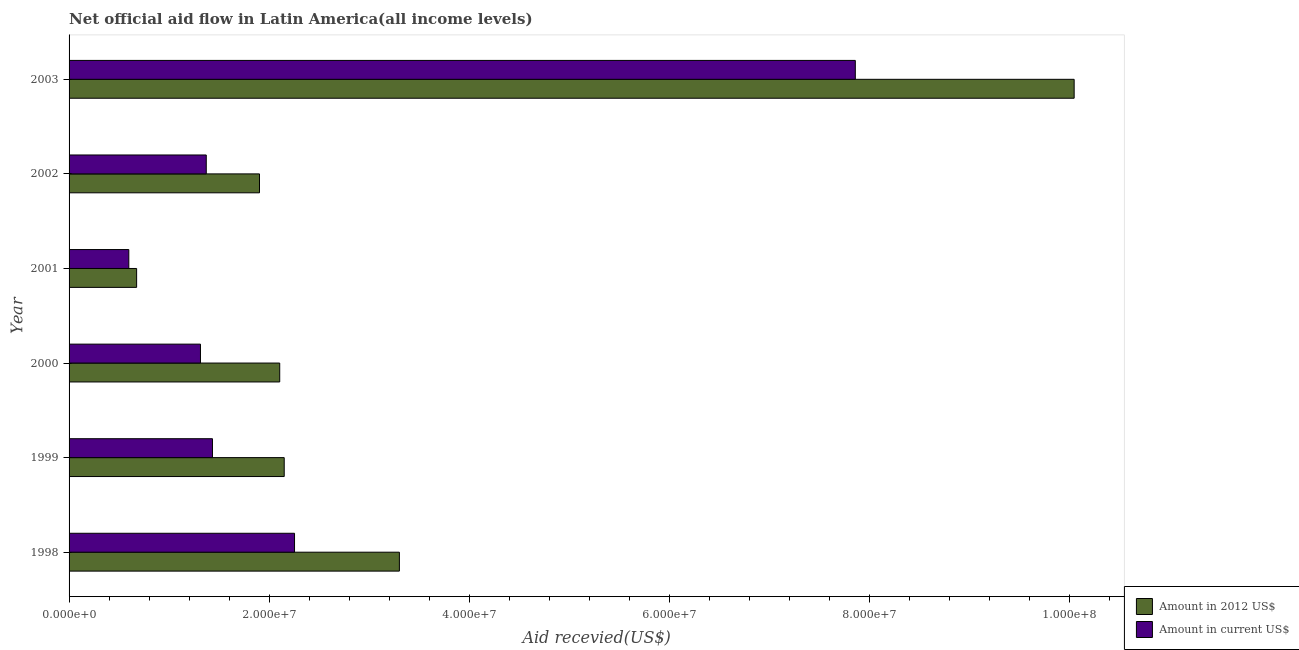How many bars are there on the 4th tick from the bottom?
Provide a short and direct response. 2. What is the amount of aid received(expressed in 2012 us$) in 1999?
Provide a short and direct response. 2.15e+07. Across all years, what is the maximum amount of aid received(expressed in 2012 us$)?
Provide a short and direct response. 1.00e+08. Across all years, what is the minimum amount of aid received(expressed in us$)?
Give a very brief answer. 5.97e+06. In which year was the amount of aid received(expressed in us$) maximum?
Your response must be concise. 2003. In which year was the amount of aid received(expressed in 2012 us$) minimum?
Keep it short and to the point. 2001. What is the total amount of aid received(expressed in 2012 us$) in the graph?
Provide a short and direct response. 2.02e+08. What is the difference between the amount of aid received(expressed in 2012 us$) in 1999 and that in 2002?
Provide a succinct answer. 2.47e+06. What is the difference between the amount of aid received(expressed in 2012 us$) in 1998 and the amount of aid received(expressed in us$) in 2000?
Your answer should be compact. 1.99e+07. What is the average amount of aid received(expressed in us$) per year?
Provide a short and direct response. 2.47e+07. In the year 2000, what is the difference between the amount of aid received(expressed in us$) and amount of aid received(expressed in 2012 us$)?
Ensure brevity in your answer.  -7.92e+06. In how many years, is the amount of aid received(expressed in 2012 us$) greater than 4000000 US$?
Provide a succinct answer. 6. What is the ratio of the amount of aid received(expressed in 2012 us$) in 1998 to that in 2001?
Provide a succinct answer. 4.89. Is the amount of aid received(expressed in 2012 us$) in 1999 less than that in 2001?
Your answer should be compact. No. What is the difference between the highest and the second highest amount of aid received(expressed in us$)?
Ensure brevity in your answer.  5.60e+07. What is the difference between the highest and the lowest amount of aid received(expressed in 2012 us$)?
Keep it short and to the point. 9.37e+07. What does the 2nd bar from the top in 2003 represents?
Your answer should be very brief. Amount in 2012 US$. What does the 2nd bar from the bottom in 2003 represents?
Your answer should be compact. Amount in current US$. How many years are there in the graph?
Provide a short and direct response. 6. Does the graph contain grids?
Provide a succinct answer. No. Where does the legend appear in the graph?
Keep it short and to the point. Bottom right. How many legend labels are there?
Provide a short and direct response. 2. What is the title of the graph?
Keep it short and to the point. Net official aid flow in Latin America(all income levels). What is the label or title of the X-axis?
Your answer should be very brief. Aid recevied(US$). What is the Aid recevied(US$) in Amount in 2012 US$ in 1998?
Provide a succinct answer. 3.30e+07. What is the Aid recevied(US$) of Amount in current US$ in 1998?
Provide a succinct answer. 2.25e+07. What is the Aid recevied(US$) of Amount in 2012 US$ in 1999?
Your answer should be compact. 2.15e+07. What is the Aid recevied(US$) in Amount in current US$ in 1999?
Provide a short and direct response. 1.43e+07. What is the Aid recevied(US$) of Amount in 2012 US$ in 2000?
Your response must be concise. 2.10e+07. What is the Aid recevied(US$) of Amount in current US$ in 2000?
Give a very brief answer. 1.31e+07. What is the Aid recevied(US$) in Amount in 2012 US$ in 2001?
Offer a terse response. 6.75e+06. What is the Aid recevied(US$) in Amount in current US$ in 2001?
Give a very brief answer. 5.97e+06. What is the Aid recevied(US$) in Amount in 2012 US$ in 2002?
Your answer should be compact. 1.90e+07. What is the Aid recevied(US$) in Amount in current US$ in 2002?
Provide a succinct answer. 1.37e+07. What is the Aid recevied(US$) of Amount in 2012 US$ in 2003?
Keep it short and to the point. 1.00e+08. What is the Aid recevied(US$) of Amount in current US$ in 2003?
Provide a succinct answer. 7.86e+07. Across all years, what is the maximum Aid recevied(US$) of Amount in 2012 US$?
Offer a very short reply. 1.00e+08. Across all years, what is the maximum Aid recevied(US$) of Amount in current US$?
Make the answer very short. 7.86e+07. Across all years, what is the minimum Aid recevied(US$) of Amount in 2012 US$?
Your answer should be compact. 6.75e+06. Across all years, what is the minimum Aid recevied(US$) of Amount in current US$?
Offer a terse response. 5.97e+06. What is the total Aid recevied(US$) in Amount in 2012 US$ in the graph?
Offer a very short reply. 2.02e+08. What is the total Aid recevied(US$) of Amount in current US$ in the graph?
Ensure brevity in your answer.  1.48e+08. What is the difference between the Aid recevied(US$) of Amount in 2012 US$ in 1998 and that in 1999?
Provide a succinct answer. 1.15e+07. What is the difference between the Aid recevied(US$) of Amount in current US$ in 1998 and that in 1999?
Keep it short and to the point. 8.20e+06. What is the difference between the Aid recevied(US$) in Amount in 2012 US$ in 1998 and that in 2000?
Keep it short and to the point. 1.20e+07. What is the difference between the Aid recevied(US$) of Amount in current US$ in 1998 and that in 2000?
Make the answer very short. 9.40e+06. What is the difference between the Aid recevied(US$) of Amount in 2012 US$ in 1998 and that in 2001?
Provide a short and direct response. 2.63e+07. What is the difference between the Aid recevied(US$) of Amount in current US$ in 1998 and that in 2001?
Offer a terse response. 1.66e+07. What is the difference between the Aid recevied(US$) in Amount in 2012 US$ in 1998 and that in 2002?
Offer a very short reply. 1.40e+07. What is the difference between the Aid recevied(US$) of Amount in current US$ in 1998 and that in 2002?
Your response must be concise. 8.82e+06. What is the difference between the Aid recevied(US$) in Amount in 2012 US$ in 1998 and that in 2003?
Give a very brief answer. -6.74e+07. What is the difference between the Aid recevied(US$) in Amount in current US$ in 1998 and that in 2003?
Your answer should be compact. -5.60e+07. What is the difference between the Aid recevied(US$) of Amount in current US$ in 1999 and that in 2000?
Your answer should be compact. 1.20e+06. What is the difference between the Aid recevied(US$) in Amount in 2012 US$ in 1999 and that in 2001?
Your answer should be compact. 1.48e+07. What is the difference between the Aid recevied(US$) of Amount in current US$ in 1999 and that in 2001?
Offer a very short reply. 8.36e+06. What is the difference between the Aid recevied(US$) in Amount in 2012 US$ in 1999 and that in 2002?
Ensure brevity in your answer.  2.47e+06. What is the difference between the Aid recevied(US$) in Amount in current US$ in 1999 and that in 2002?
Offer a terse response. 6.20e+05. What is the difference between the Aid recevied(US$) in Amount in 2012 US$ in 1999 and that in 2003?
Make the answer very short. -7.89e+07. What is the difference between the Aid recevied(US$) of Amount in current US$ in 1999 and that in 2003?
Provide a succinct answer. -6.42e+07. What is the difference between the Aid recevied(US$) of Amount in 2012 US$ in 2000 and that in 2001?
Provide a succinct answer. 1.43e+07. What is the difference between the Aid recevied(US$) of Amount in current US$ in 2000 and that in 2001?
Keep it short and to the point. 7.16e+06. What is the difference between the Aid recevied(US$) in Amount in 2012 US$ in 2000 and that in 2002?
Offer a terse response. 2.02e+06. What is the difference between the Aid recevied(US$) of Amount in current US$ in 2000 and that in 2002?
Make the answer very short. -5.80e+05. What is the difference between the Aid recevied(US$) of Amount in 2012 US$ in 2000 and that in 2003?
Your response must be concise. -7.94e+07. What is the difference between the Aid recevied(US$) of Amount in current US$ in 2000 and that in 2003?
Your answer should be compact. -6.54e+07. What is the difference between the Aid recevied(US$) of Amount in 2012 US$ in 2001 and that in 2002?
Ensure brevity in your answer.  -1.23e+07. What is the difference between the Aid recevied(US$) in Amount in current US$ in 2001 and that in 2002?
Ensure brevity in your answer.  -7.74e+06. What is the difference between the Aid recevied(US$) in Amount in 2012 US$ in 2001 and that in 2003?
Ensure brevity in your answer.  -9.37e+07. What is the difference between the Aid recevied(US$) of Amount in current US$ in 2001 and that in 2003?
Your answer should be very brief. -7.26e+07. What is the difference between the Aid recevied(US$) in Amount in 2012 US$ in 2002 and that in 2003?
Give a very brief answer. -8.14e+07. What is the difference between the Aid recevied(US$) of Amount in current US$ in 2002 and that in 2003?
Keep it short and to the point. -6.49e+07. What is the difference between the Aid recevied(US$) in Amount in 2012 US$ in 1998 and the Aid recevied(US$) in Amount in current US$ in 1999?
Offer a very short reply. 1.87e+07. What is the difference between the Aid recevied(US$) in Amount in 2012 US$ in 1998 and the Aid recevied(US$) in Amount in current US$ in 2000?
Offer a very short reply. 1.99e+07. What is the difference between the Aid recevied(US$) in Amount in 2012 US$ in 1998 and the Aid recevied(US$) in Amount in current US$ in 2001?
Offer a terse response. 2.70e+07. What is the difference between the Aid recevied(US$) of Amount in 2012 US$ in 1998 and the Aid recevied(US$) of Amount in current US$ in 2002?
Your answer should be very brief. 1.93e+07. What is the difference between the Aid recevied(US$) in Amount in 2012 US$ in 1998 and the Aid recevied(US$) in Amount in current US$ in 2003?
Provide a short and direct response. -4.56e+07. What is the difference between the Aid recevied(US$) in Amount in 2012 US$ in 1999 and the Aid recevied(US$) in Amount in current US$ in 2000?
Your response must be concise. 8.37e+06. What is the difference between the Aid recevied(US$) of Amount in 2012 US$ in 1999 and the Aid recevied(US$) of Amount in current US$ in 2001?
Offer a very short reply. 1.55e+07. What is the difference between the Aid recevied(US$) of Amount in 2012 US$ in 1999 and the Aid recevied(US$) of Amount in current US$ in 2002?
Make the answer very short. 7.79e+06. What is the difference between the Aid recevied(US$) in Amount in 2012 US$ in 1999 and the Aid recevied(US$) in Amount in current US$ in 2003?
Offer a very short reply. -5.71e+07. What is the difference between the Aid recevied(US$) in Amount in 2012 US$ in 2000 and the Aid recevied(US$) in Amount in current US$ in 2001?
Provide a succinct answer. 1.51e+07. What is the difference between the Aid recevied(US$) in Amount in 2012 US$ in 2000 and the Aid recevied(US$) in Amount in current US$ in 2002?
Give a very brief answer. 7.34e+06. What is the difference between the Aid recevied(US$) in Amount in 2012 US$ in 2000 and the Aid recevied(US$) in Amount in current US$ in 2003?
Offer a terse response. -5.75e+07. What is the difference between the Aid recevied(US$) in Amount in 2012 US$ in 2001 and the Aid recevied(US$) in Amount in current US$ in 2002?
Offer a very short reply. -6.96e+06. What is the difference between the Aid recevied(US$) in Amount in 2012 US$ in 2001 and the Aid recevied(US$) in Amount in current US$ in 2003?
Offer a terse response. -7.18e+07. What is the difference between the Aid recevied(US$) in Amount in 2012 US$ in 2002 and the Aid recevied(US$) in Amount in current US$ in 2003?
Make the answer very short. -5.95e+07. What is the average Aid recevied(US$) in Amount in 2012 US$ per year?
Keep it short and to the point. 3.36e+07. What is the average Aid recevied(US$) in Amount in current US$ per year?
Your answer should be very brief. 2.47e+07. In the year 1998, what is the difference between the Aid recevied(US$) of Amount in 2012 US$ and Aid recevied(US$) of Amount in current US$?
Offer a very short reply. 1.05e+07. In the year 1999, what is the difference between the Aid recevied(US$) in Amount in 2012 US$ and Aid recevied(US$) in Amount in current US$?
Give a very brief answer. 7.17e+06. In the year 2000, what is the difference between the Aid recevied(US$) of Amount in 2012 US$ and Aid recevied(US$) of Amount in current US$?
Offer a very short reply. 7.92e+06. In the year 2001, what is the difference between the Aid recevied(US$) of Amount in 2012 US$ and Aid recevied(US$) of Amount in current US$?
Give a very brief answer. 7.80e+05. In the year 2002, what is the difference between the Aid recevied(US$) of Amount in 2012 US$ and Aid recevied(US$) of Amount in current US$?
Ensure brevity in your answer.  5.32e+06. In the year 2003, what is the difference between the Aid recevied(US$) of Amount in 2012 US$ and Aid recevied(US$) of Amount in current US$?
Keep it short and to the point. 2.19e+07. What is the ratio of the Aid recevied(US$) of Amount in 2012 US$ in 1998 to that in 1999?
Your answer should be compact. 1.54. What is the ratio of the Aid recevied(US$) of Amount in current US$ in 1998 to that in 1999?
Your response must be concise. 1.57. What is the ratio of the Aid recevied(US$) in Amount in 2012 US$ in 1998 to that in 2000?
Give a very brief answer. 1.57. What is the ratio of the Aid recevied(US$) of Amount in current US$ in 1998 to that in 2000?
Provide a short and direct response. 1.72. What is the ratio of the Aid recevied(US$) of Amount in 2012 US$ in 1998 to that in 2001?
Give a very brief answer. 4.89. What is the ratio of the Aid recevied(US$) in Amount in current US$ in 1998 to that in 2001?
Offer a very short reply. 3.77. What is the ratio of the Aid recevied(US$) of Amount in 2012 US$ in 1998 to that in 2002?
Make the answer very short. 1.73. What is the ratio of the Aid recevied(US$) in Amount in current US$ in 1998 to that in 2002?
Provide a succinct answer. 1.64. What is the ratio of the Aid recevied(US$) in Amount in 2012 US$ in 1998 to that in 2003?
Ensure brevity in your answer.  0.33. What is the ratio of the Aid recevied(US$) in Amount in current US$ in 1998 to that in 2003?
Make the answer very short. 0.29. What is the ratio of the Aid recevied(US$) in Amount in 2012 US$ in 1999 to that in 2000?
Provide a short and direct response. 1.02. What is the ratio of the Aid recevied(US$) of Amount in current US$ in 1999 to that in 2000?
Provide a succinct answer. 1.09. What is the ratio of the Aid recevied(US$) in Amount in 2012 US$ in 1999 to that in 2001?
Make the answer very short. 3.19. What is the ratio of the Aid recevied(US$) of Amount in current US$ in 1999 to that in 2001?
Keep it short and to the point. 2.4. What is the ratio of the Aid recevied(US$) of Amount in 2012 US$ in 1999 to that in 2002?
Ensure brevity in your answer.  1.13. What is the ratio of the Aid recevied(US$) in Amount in current US$ in 1999 to that in 2002?
Provide a short and direct response. 1.05. What is the ratio of the Aid recevied(US$) in Amount in 2012 US$ in 1999 to that in 2003?
Provide a succinct answer. 0.21. What is the ratio of the Aid recevied(US$) of Amount in current US$ in 1999 to that in 2003?
Offer a very short reply. 0.18. What is the ratio of the Aid recevied(US$) of Amount in 2012 US$ in 2000 to that in 2001?
Offer a terse response. 3.12. What is the ratio of the Aid recevied(US$) in Amount in current US$ in 2000 to that in 2001?
Your response must be concise. 2.2. What is the ratio of the Aid recevied(US$) of Amount in 2012 US$ in 2000 to that in 2002?
Your answer should be very brief. 1.11. What is the ratio of the Aid recevied(US$) of Amount in current US$ in 2000 to that in 2002?
Give a very brief answer. 0.96. What is the ratio of the Aid recevied(US$) of Amount in 2012 US$ in 2000 to that in 2003?
Your answer should be compact. 0.21. What is the ratio of the Aid recevied(US$) of Amount in current US$ in 2000 to that in 2003?
Give a very brief answer. 0.17. What is the ratio of the Aid recevied(US$) of Amount in 2012 US$ in 2001 to that in 2002?
Your response must be concise. 0.35. What is the ratio of the Aid recevied(US$) in Amount in current US$ in 2001 to that in 2002?
Your response must be concise. 0.44. What is the ratio of the Aid recevied(US$) in Amount in 2012 US$ in 2001 to that in 2003?
Keep it short and to the point. 0.07. What is the ratio of the Aid recevied(US$) of Amount in current US$ in 2001 to that in 2003?
Give a very brief answer. 0.08. What is the ratio of the Aid recevied(US$) of Amount in 2012 US$ in 2002 to that in 2003?
Ensure brevity in your answer.  0.19. What is the ratio of the Aid recevied(US$) in Amount in current US$ in 2002 to that in 2003?
Keep it short and to the point. 0.17. What is the difference between the highest and the second highest Aid recevied(US$) of Amount in 2012 US$?
Make the answer very short. 6.74e+07. What is the difference between the highest and the second highest Aid recevied(US$) in Amount in current US$?
Provide a succinct answer. 5.60e+07. What is the difference between the highest and the lowest Aid recevied(US$) in Amount in 2012 US$?
Provide a short and direct response. 9.37e+07. What is the difference between the highest and the lowest Aid recevied(US$) in Amount in current US$?
Keep it short and to the point. 7.26e+07. 